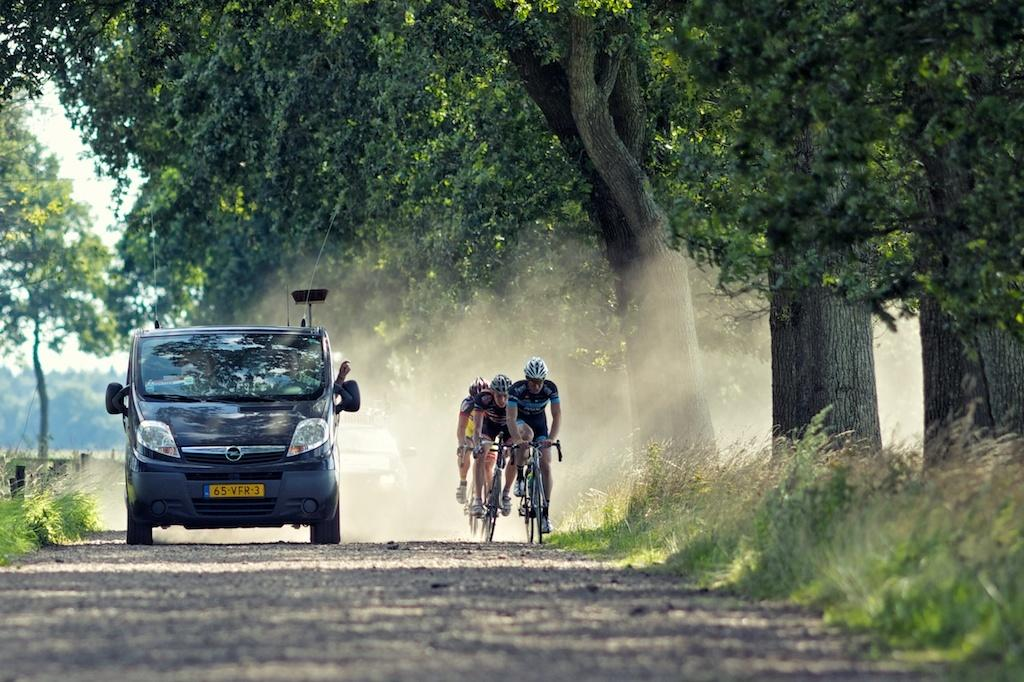What is the main subject of the image? There is a vehicle in the image. What are the people in the image doing? There are three persons on a cycle in the image. Where are the persons and the cycle located? The persons and the cycle are on the road. What can be seen in the background of the image? There is grass and trees visible in the background of the image. What type of umbrella is being used by the persons on the cycle in the image? There is no umbrella present in the image; the persons on the cycle are not using any umbrellas. What emotion can be seen on the faces of the persons on the cycle in the image? The provided facts do not mention any emotions or facial expressions of the persons on the cycle, so it cannot be determined from the image. 